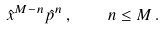<formula> <loc_0><loc_0><loc_500><loc_500>\hat { x } ^ { M - n } \hat { p } ^ { n } \, , \quad n \leq M \, .</formula> 